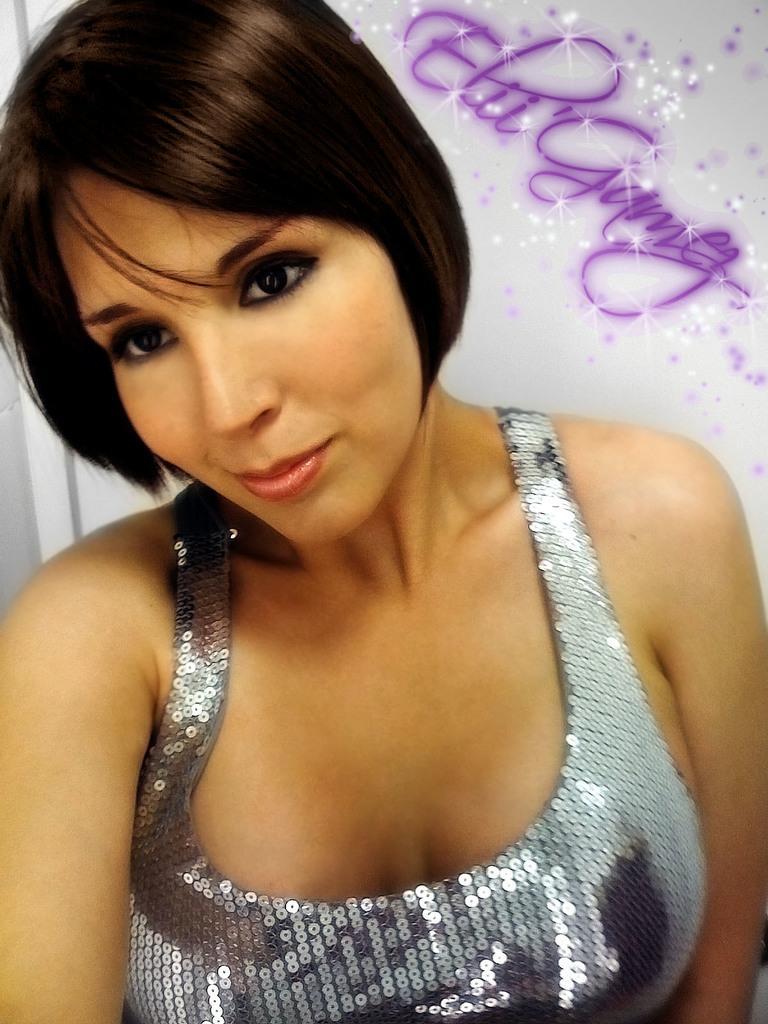Describe this image in one or two sentences. In the given image i can see a lady and behind her i can see some text. 